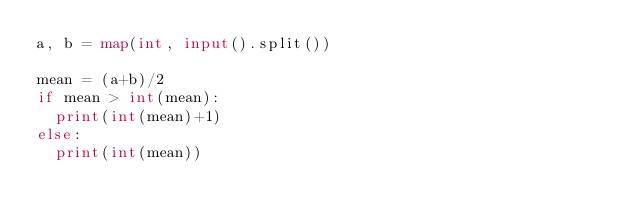Convert code to text. <code><loc_0><loc_0><loc_500><loc_500><_Python_>a, b = map(int, input().split())

mean = (a+b)/2
if mean > int(mean):
  print(int(mean)+1)
else:
  print(int(mean))</code> 